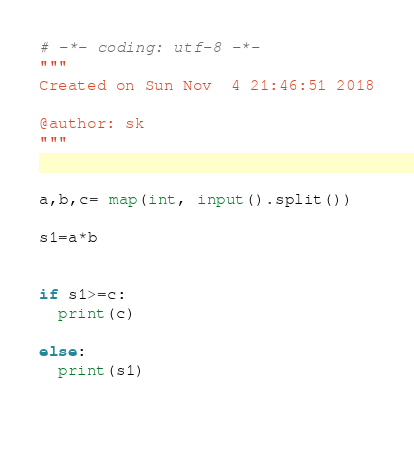<code> <loc_0><loc_0><loc_500><loc_500><_Python_># -*- coding: utf-8 -*-
"""
Created on Sun Nov  4 21:46:51 2018

@author: sk
"""


a,b,c= map(int, input().split())

s1=a*b


if s1>=c:
  print(c)

else:
  print(s1)
  
       



</code> 